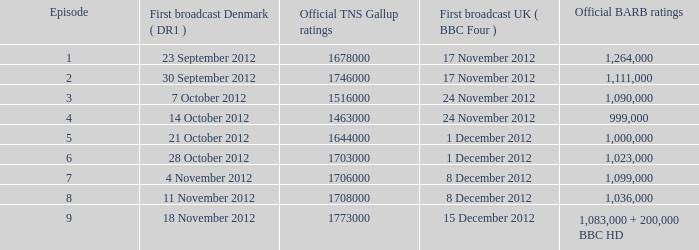When was the episode with a 999,000 BARB rating first aired in Denmark? 14 October 2012. Can you parse all the data within this table? {'header': ['Episode', 'First broadcast Denmark ( DR1 )', 'Official TNS Gallup ratings', 'First broadcast UK ( BBC Four )', 'Official BARB ratings'], 'rows': [['1', '23 September 2012', '1678000', '17 November 2012', '1,264,000'], ['2', '30 September 2012', '1746000', '17 November 2012', '1,111,000'], ['3', '7 October 2012', '1516000', '24 November 2012', '1,090,000'], ['4', '14 October 2012', '1463000', '24 November 2012', '999,000'], ['5', '21 October 2012', '1644000', '1 December 2012', '1,000,000'], ['6', '28 October 2012', '1703000', '1 December 2012', '1,023,000'], ['7', '4 November 2012', '1706000', '8 December 2012', '1,099,000'], ['8', '11 November 2012', '1708000', '8 December 2012', '1,036,000'], ['9', '18 November 2012', '1773000', '15 December 2012', '1,083,000 + 200,000 BBC HD']]} 